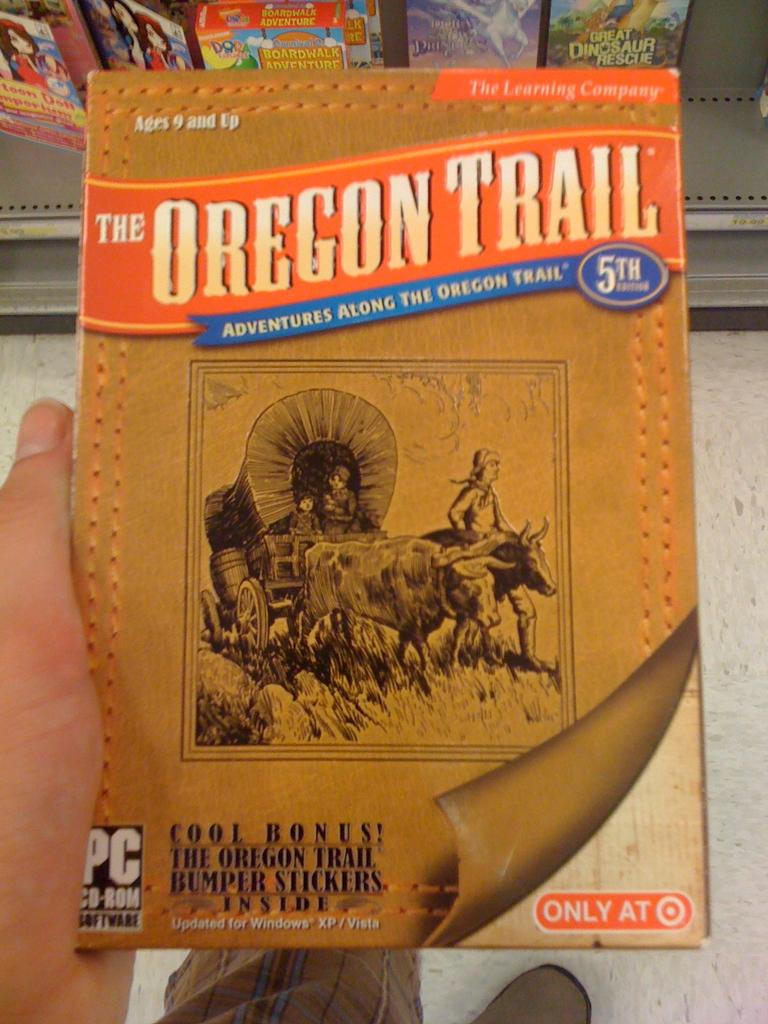Provide a one-sentence caption for the provided image. A computer game is titled The Oregon Trail and has a picture of a wagon being pulled on it. 